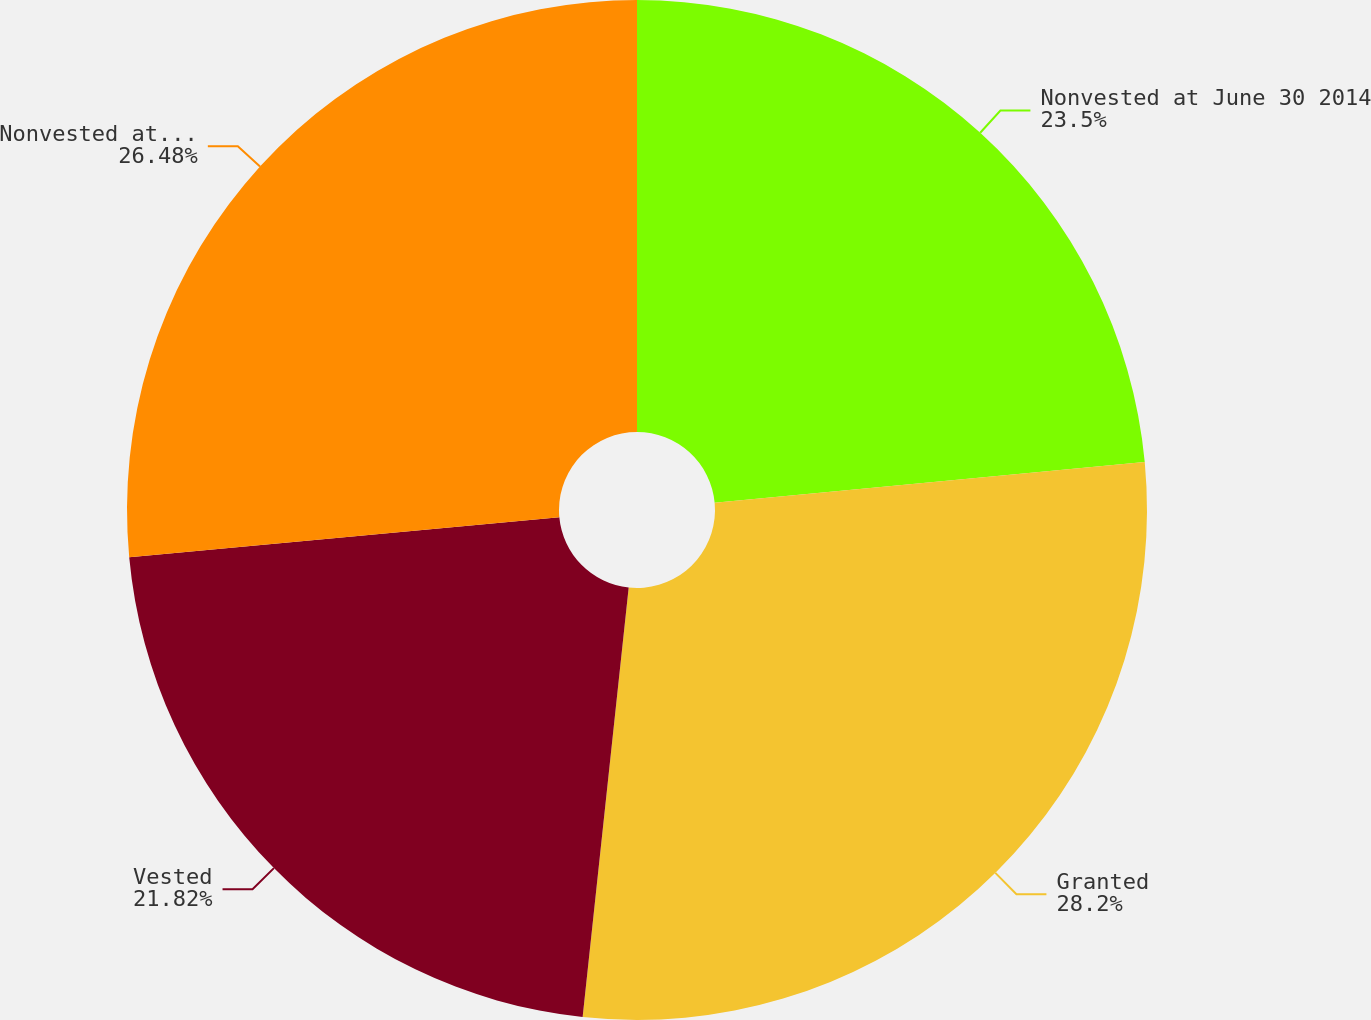Convert chart. <chart><loc_0><loc_0><loc_500><loc_500><pie_chart><fcel>Nonvested at June 30 2014<fcel>Granted<fcel>Vested<fcel>Nonvested at June 30 2015<nl><fcel>23.5%<fcel>28.2%<fcel>21.82%<fcel>26.48%<nl></chart> 